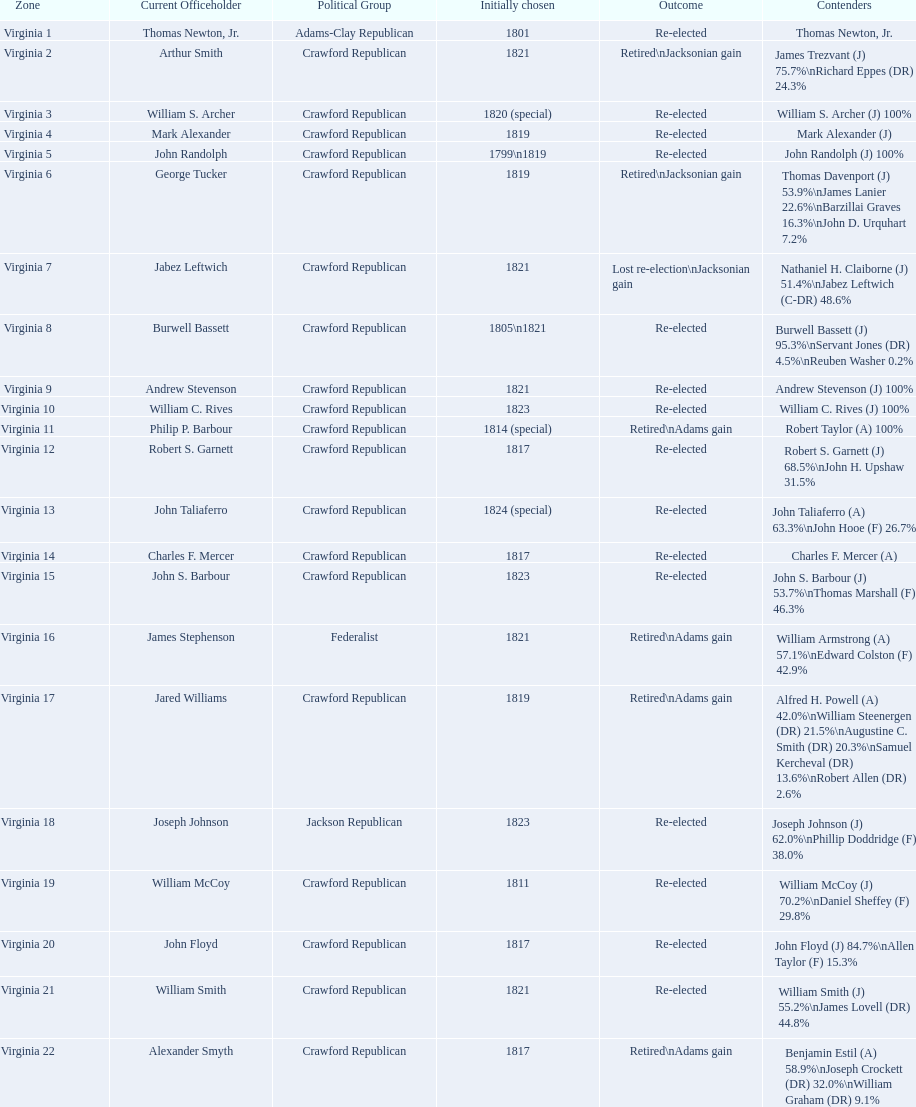Which incumbents belonged to the crawford republican party? Arthur Smith, William S. Archer, Mark Alexander, John Randolph, George Tucker, Jabez Leftwich, Burwell Bassett, Andrew Stevenson, William C. Rives, Philip P. Barbour, Robert S. Garnett, John Taliaferro, Charles F. Mercer, John S. Barbour, Jared Williams, William McCoy, John Floyd, William Smith, Alexander Smyth. Which of these incumbents were first elected in 1821? Arthur Smith, Jabez Leftwich, Andrew Stevenson, William Smith. Which of these incumbents have a last name of smith? Arthur Smith, William Smith. Which of these two were not re-elected? Arthur Smith. 